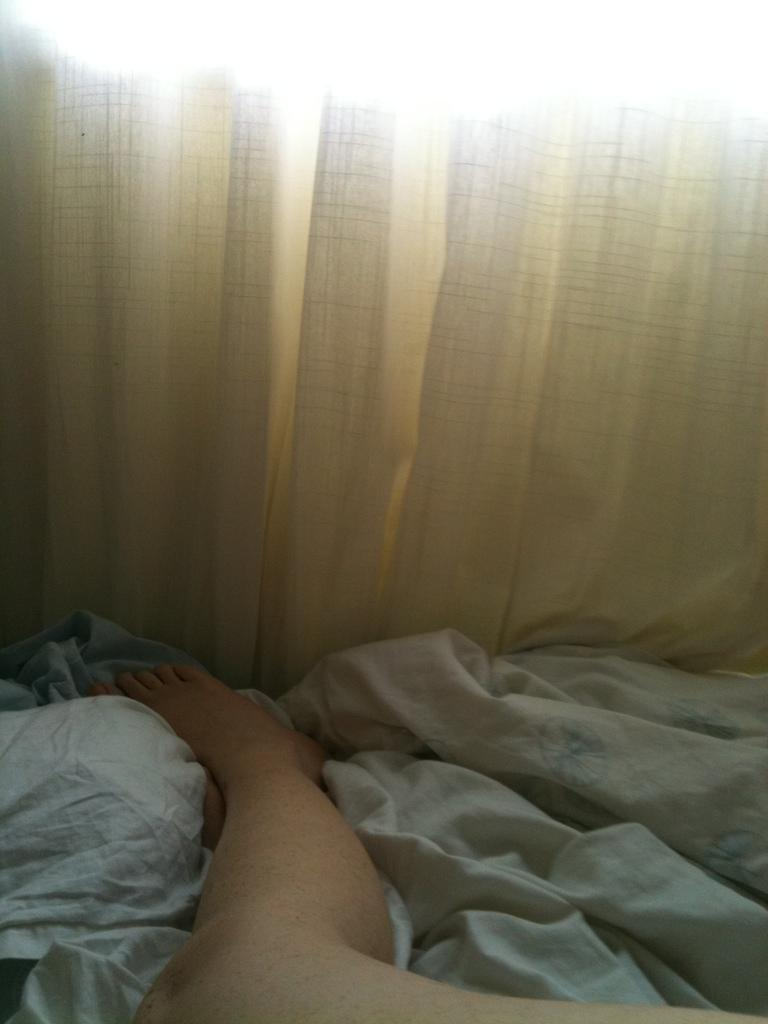What part of a person can be seen in the image? There are legs of a person in the image. What type of covering is present in the image? There is a blanket in the image. What type of window treatment is visible in the image? There is a curtain on the backside in the image. What action is the woman performing in the image? There is no woman present in the image, only legs of a person can be seen. 